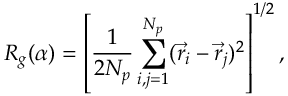<formula> <loc_0><loc_0><loc_500><loc_500>R _ { g } ( \alpha ) = \left [ \frac { 1 } { 2 N _ { p } } \sum _ { i , j = 1 } ^ { N _ { p } } ( \vec { r } _ { i } - \vec { r } _ { j } ) ^ { 2 } \right ] ^ { 1 / 2 } ,</formula> 